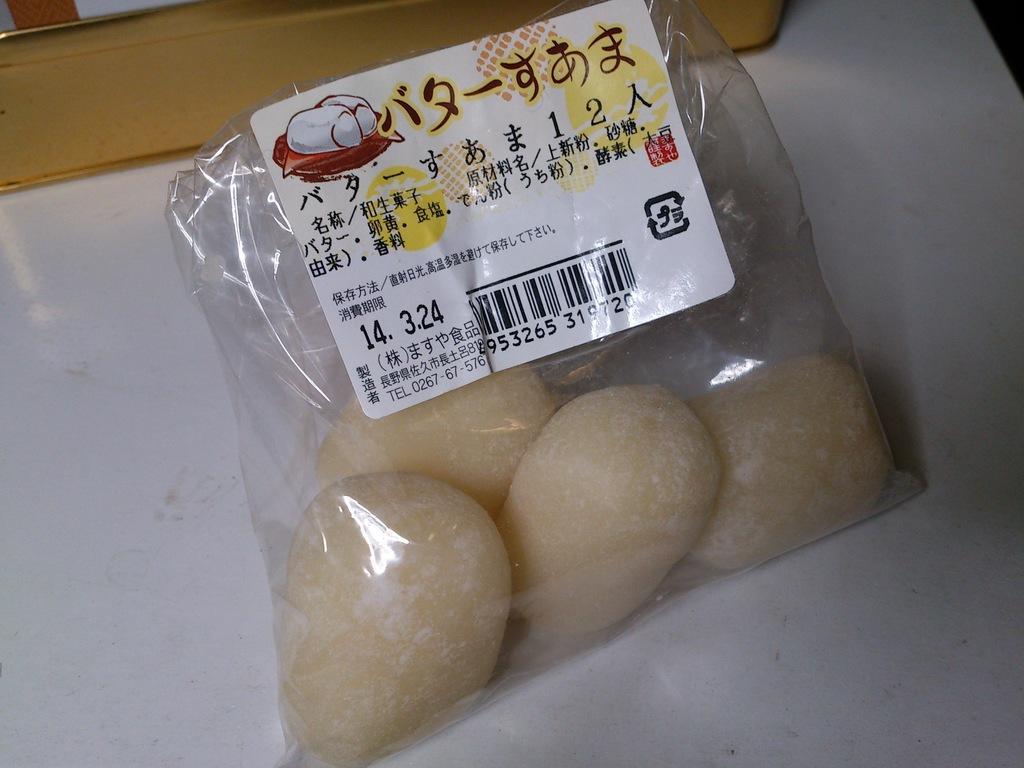Please provide a concise description of this image. In this image we can see some food inside a cover which is placed on the table. We can also see a sticker pasted on the cover containing some text and a bar code. 